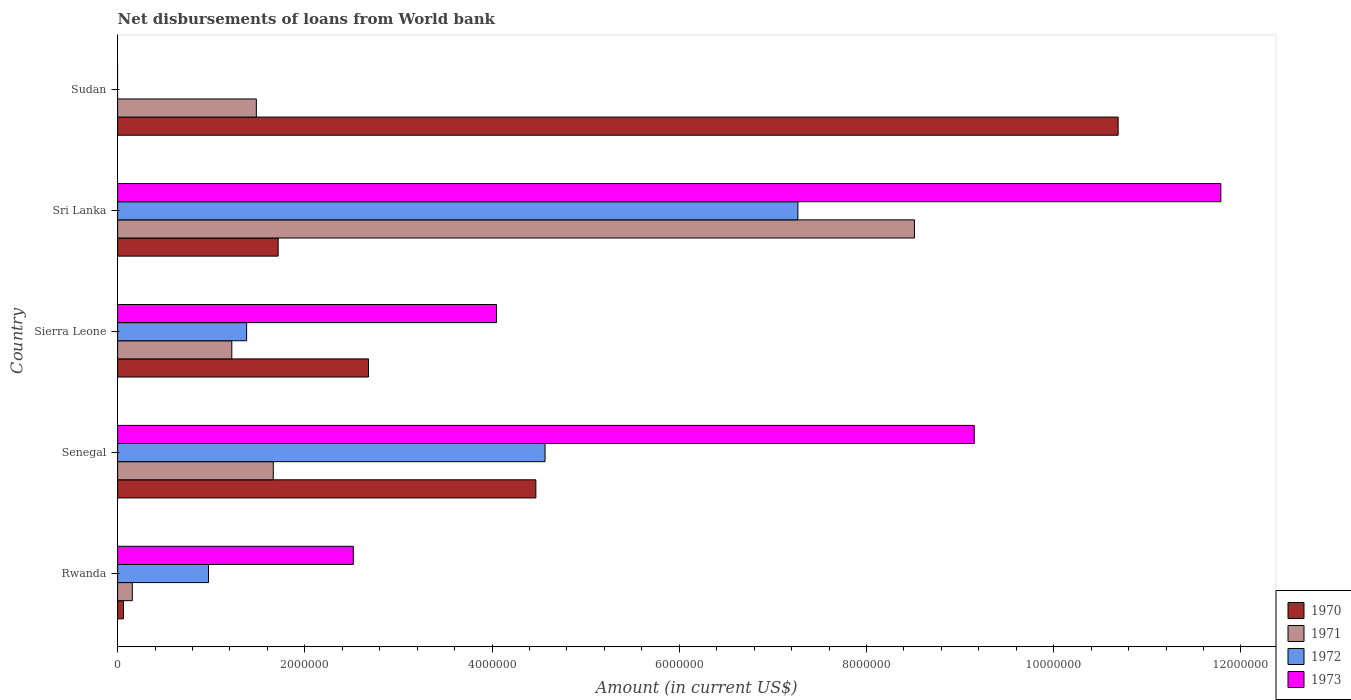How many different coloured bars are there?
Give a very brief answer. 4. How many groups of bars are there?
Your answer should be compact. 5. How many bars are there on the 5th tick from the top?
Ensure brevity in your answer.  4. What is the label of the 2nd group of bars from the top?
Ensure brevity in your answer.  Sri Lanka. What is the amount of loan disbursed from World Bank in 1972 in Sierra Leone?
Offer a very short reply. 1.38e+06. Across all countries, what is the maximum amount of loan disbursed from World Bank in 1971?
Your answer should be compact. 8.51e+06. Across all countries, what is the minimum amount of loan disbursed from World Bank in 1970?
Offer a very short reply. 6.30e+04. In which country was the amount of loan disbursed from World Bank in 1971 maximum?
Offer a very short reply. Sri Lanka. What is the total amount of loan disbursed from World Bank in 1970 in the graph?
Your answer should be very brief. 1.96e+07. What is the difference between the amount of loan disbursed from World Bank in 1971 in Senegal and that in Sri Lanka?
Your answer should be compact. -6.85e+06. What is the difference between the amount of loan disbursed from World Bank in 1971 in Sudan and the amount of loan disbursed from World Bank in 1973 in Rwanda?
Keep it short and to the point. -1.04e+06. What is the average amount of loan disbursed from World Bank in 1971 per country?
Provide a succinct answer. 2.61e+06. What is the difference between the amount of loan disbursed from World Bank in 1970 and amount of loan disbursed from World Bank in 1971 in Sudan?
Your answer should be compact. 9.21e+06. In how many countries, is the amount of loan disbursed from World Bank in 1971 greater than 8400000 US$?
Give a very brief answer. 1. What is the ratio of the amount of loan disbursed from World Bank in 1973 in Rwanda to that in Senegal?
Offer a very short reply. 0.28. Is the difference between the amount of loan disbursed from World Bank in 1970 in Senegal and Sri Lanka greater than the difference between the amount of loan disbursed from World Bank in 1971 in Senegal and Sri Lanka?
Give a very brief answer. Yes. What is the difference between the highest and the second highest amount of loan disbursed from World Bank in 1971?
Your response must be concise. 6.85e+06. What is the difference between the highest and the lowest amount of loan disbursed from World Bank in 1970?
Your answer should be very brief. 1.06e+07. Are all the bars in the graph horizontal?
Keep it short and to the point. Yes. What is the difference between two consecutive major ticks on the X-axis?
Provide a short and direct response. 2.00e+06. Where does the legend appear in the graph?
Your answer should be compact. Bottom right. How are the legend labels stacked?
Make the answer very short. Vertical. What is the title of the graph?
Your answer should be very brief. Net disbursements of loans from World bank. What is the label or title of the Y-axis?
Offer a very short reply. Country. What is the Amount (in current US$) of 1970 in Rwanda?
Keep it short and to the point. 6.30e+04. What is the Amount (in current US$) of 1971 in Rwanda?
Provide a short and direct response. 1.57e+05. What is the Amount (in current US$) of 1972 in Rwanda?
Give a very brief answer. 9.71e+05. What is the Amount (in current US$) in 1973 in Rwanda?
Ensure brevity in your answer.  2.52e+06. What is the Amount (in current US$) in 1970 in Senegal?
Ensure brevity in your answer.  4.47e+06. What is the Amount (in current US$) in 1971 in Senegal?
Make the answer very short. 1.66e+06. What is the Amount (in current US$) of 1972 in Senegal?
Make the answer very short. 4.57e+06. What is the Amount (in current US$) in 1973 in Senegal?
Offer a terse response. 9.15e+06. What is the Amount (in current US$) of 1970 in Sierra Leone?
Make the answer very short. 2.68e+06. What is the Amount (in current US$) of 1971 in Sierra Leone?
Your answer should be very brief. 1.22e+06. What is the Amount (in current US$) of 1972 in Sierra Leone?
Make the answer very short. 1.38e+06. What is the Amount (in current US$) in 1973 in Sierra Leone?
Provide a short and direct response. 4.05e+06. What is the Amount (in current US$) of 1970 in Sri Lanka?
Provide a short and direct response. 1.72e+06. What is the Amount (in current US$) of 1971 in Sri Lanka?
Offer a very short reply. 8.51e+06. What is the Amount (in current US$) of 1972 in Sri Lanka?
Make the answer very short. 7.27e+06. What is the Amount (in current US$) of 1973 in Sri Lanka?
Your answer should be very brief. 1.18e+07. What is the Amount (in current US$) in 1970 in Sudan?
Ensure brevity in your answer.  1.07e+07. What is the Amount (in current US$) in 1971 in Sudan?
Offer a very short reply. 1.48e+06. Across all countries, what is the maximum Amount (in current US$) of 1970?
Offer a very short reply. 1.07e+07. Across all countries, what is the maximum Amount (in current US$) of 1971?
Your answer should be compact. 8.51e+06. Across all countries, what is the maximum Amount (in current US$) of 1972?
Give a very brief answer. 7.27e+06. Across all countries, what is the maximum Amount (in current US$) of 1973?
Your answer should be compact. 1.18e+07. Across all countries, what is the minimum Amount (in current US$) of 1970?
Your answer should be compact. 6.30e+04. Across all countries, what is the minimum Amount (in current US$) of 1971?
Your answer should be compact. 1.57e+05. What is the total Amount (in current US$) in 1970 in the graph?
Your response must be concise. 1.96e+07. What is the total Amount (in current US$) in 1971 in the graph?
Give a very brief answer. 1.30e+07. What is the total Amount (in current US$) of 1972 in the graph?
Your answer should be very brief. 1.42e+07. What is the total Amount (in current US$) of 1973 in the graph?
Give a very brief answer. 2.75e+07. What is the difference between the Amount (in current US$) of 1970 in Rwanda and that in Senegal?
Your answer should be very brief. -4.40e+06. What is the difference between the Amount (in current US$) in 1971 in Rwanda and that in Senegal?
Give a very brief answer. -1.51e+06. What is the difference between the Amount (in current US$) of 1972 in Rwanda and that in Senegal?
Ensure brevity in your answer.  -3.60e+06. What is the difference between the Amount (in current US$) in 1973 in Rwanda and that in Senegal?
Ensure brevity in your answer.  -6.63e+06. What is the difference between the Amount (in current US$) of 1970 in Rwanda and that in Sierra Leone?
Provide a short and direct response. -2.62e+06. What is the difference between the Amount (in current US$) in 1971 in Rwanda and that in Sierra Leone?
Ensure brevity in your answer.  -1.06e+06. What is the difference between the Amount (in current US$) in 1972 in Rwanda and that in Sierra Leone?
Make the answer very short. -4.07e+05. What is the difference between the Amount (in current US$) of 1973 in Rwanda and that in Sierra Leone?
Your answer should be very brief. -1.53e+06. What is the difference between the Amount (in current US$) of 1970 in Rwanda and that in Sri Lanka?
Keep it short and to the point. -1.65e+06. What is the difference between the Amount (in current US$) of 1971 in Rwanda and that in Sri Lanka?
Ensure brevity in your answer.  -8.36e+06. What is the difference between the Amount (in current US$) in 1972 in Rwanda and that in Sri Lanka?
Keep it short and to the point. -6.30e+06. What is the difference between the Amount (in current US$) in 1973 in Rwanda and that in Sri Lanka?
Provide a succinct answer. -9.27e+06. What is the difference between the Amount (in current US$) of 1970 in Rwanda and that in Sudan?
Give a very brief answer. -1.06e+07. What is the difference between the Amount (in current US$) in 1971 in Rwanda and that in Sudan?
Offer a terse response. -1.32e+06. What is the difference between the Amount (in current US$) of 1970 in Senegal and that in Sierra Leone?
Your answer should be very brief. 1.79e+06. What is the difference between the Amount (in current US$) in 1971 in Senegal and that in Sierra Leone?
Your answer should be compact. 4.43e+05. What is the difference between the Amount (in current US$) of 1972 in Senegal and that in Sierra Leone?
Provide a succinct answer. 3.19e+06. What is the difference between the Amount (in current US$) of 1973 in Senegal and that in Sierra Leone?
Give a very brief answer. 5.10e+06. What is the difference between the Amount (in current US$) of 1970 in Senegal and that in Sri Lanka?
Your answer should be compact. 2.75e+06. What is the difference between the Amount (in current US$) of 1971 in Senegal and that in Sri Lanka?
Give a very brief answer. -6.85e+06. What is the difference between the Amount (in current US$) of 1972 in Senegal and that in Sri Lanka?
Make the answer very short. -2.70e+06. What is the difference between the Amount (in current US$) in 1973 in Senegal and that in Sri Lanka?
Offer a very short reply. -2.63e+06. What is the difference between the Amount (in current US$) of 1970 in Senegal and that in Sudan?
Your answer should be compact. -6.22e+06. What is the difference between the Amount (in current US$) in 1971 in Senegal and that in Sudan?
Your answer should be very brief. 1.81e+05. What is the difference between the Amount (in current US$) in 1970 in Sierra Leone and that in Sri Lanka?
Keep it short and to the point. 9.65e+05. What is the difference between the Amount (in current US$) of 1971 in Sierra Leone and that in Sri Lanka?
Your response must be concise. -7.29e+06. What is the difference between the Amount (in current US$) of 1972 in Sierra Leone and that in Sri Lanka?
Give a very brief answer. -5.89e+06. What is the difference between the Amount (in current US$) in 1973 in Sierra Leone and that in Sri Lanka?
Offer a terse response. -7.74e+06. What is the difference between the Amount (in current US$) of 1970 in Sierra Leone and that in Sudan?
Offer a terse response. -8.01e+06. What is the difference between the Amount (in current US$) in 1971 in Sierra Leone and that in Sudan?
Provide a succinct answer. -2.62e+05. What is the difference between the Amount (in current US$) in 1970 in Sri Lanka and that in Sudan?
Your answer should be very brief. -8.97e+06. What is the difference between the Amount (in current US$) of 1971 in Sri Lanka and that in Sudan?
Offer a terse response. 7.03e+06. What is the difference between the Amount (in current US$) in 1970 in Rwanda and the Amount (in current US$) in 1971 in Senegal?
Provide a succinct answer. -1.60e+06. What is the difference between the Amount (in current US$) of 1970 in Rwanda and the Amount (in current US$) of 1972 in Senegal?
Make the answer very short. -4.50e+06. What is the difference between the Amount (in current US$) in 1970 in Rwanda and the Amount (in current US$) in 1973 in Senegal?
Offer a terse response. -9.09e+06. What is the difference between the Amount (in current US$) in 1971 in Rwanda and the Amount (in current US$) in 1972 in Senegal?
Offer a terse response. -4.41e+06. What is the difference between the Amount (in current US$) in 1971 in Rwanda and the Amount (in current US$) in 1973 in Senegal?
Your response must be concise. -8.99e+06. What is the difference between the Amount (in current US$) in 1972 in Rwanda and the Amount (in current US$) in 1973 in Senegal?
Your answer should be compact. -8.18e+06. What is the difference between the Amount (in current US$) in 1970 in Rwanda and the Amount (in current US$) in 1971 in Sierra Leone?
Give a very brief answer. -1.16e+06. What is the difference between the Amount (in current US$) in 1970 in Rwanda and the Amount (in current US$) in 1972 in Sierra Leone?
Your answer should be compact. -1.32e+06. What is the difference between the Amount (in current US$) of 1970 in Rwanda and the Amount (in current US$) of 1973 in Sierra Leone?
Provide a short and direct response. -3.98e+06. What is the difference between the Amount (in current US$) of 1971 in Rwanda and the Amount (in current US$) of 1972 in Sierra Leone?
Offer a terse response. -1.22e+06. What is the difference between the Amount (in current US$) of 1971 in Rwanda and the Amount (in current US$) of 1973 in Sierra Leone?
Your response must be concise. -3.89e+06. What is the difference between the Amount (in current US$) of 1972 in Rwanda and the Amount (in current US$) of 1973 in Sierra Leone?
Your response must be concise. -3.08e+06. What is the difference between the Amount (in current US$) of 1970 in Rwanda and the Amount (in current US$) of 1971 in Sri Lanka?
Make the answer very short. -8.45e+06. What is the difference between the Amount (in current US$) of 1970 in Rwanda and the Amount (in current US$) of 1972 in Sri Lanka?
Your response must be concise. -7.20e+06. What is the difference between the Amount (in current US$) of 1970 in Rwanda and the Amount (in current US$) of 1973 in Sri Lanka?
Your response must be concise. -1.17e+07. What is the difference between the Amount (in current US$) in 1971 in Rwanda and the Amount (in current US$) in 1972 in Sri Lanka?
Your answer should be compact. -7.11e+06. What is the difference between the Amount (in current US$) in 1971 in Rwanda and the Amount (in current US$) in 1973 in Sri Lanka?
Your response must be concise. -1.16e+07. What is the difference between the Amount (in current US$) in 1972 in Rwanda and the Amount (in current US$) in 1973 in Sri Lanka?
Offer a very short reply. -1.08e+07. What is the difference between the Amount (in current US$) of 1970 in Rwanda and the Amount (in current US$) of 1971 in Sudan?
Your answer should be compact. -1.42e+06. What is the difference between the Amount (in current US$) in 1970 in Senegal and the Amount (in current US$) in 1971 in Sierra Leone?
Provide a succinct answer. 3.25e+06. What is the difference between the Amount (in current US$) in 1970 in Senegal and the Amount (in current US$) in 1972 in Sierra Leone?
Offer a very short reply. 3.09e+06. What is the difference between the Amount (in current US$) of 1971 in Senegal and the Amount (in current US$) of 1972 in Sierra Leone?
Offer a terse response. 2.85e+05. What is the difference between the Amount (in current US$) in 1971 in Senegal and the Amount (in current US$) in 1973 in Sierra Leone?
Give a very brief answer. -2.38e+06. What is the difference between the Amount (in current US$) of 1972 in Senegal and the Amount (in current US$) of 1973 in Sierra Leone?
Offer a terse response. 5.18e+05. What is the difference between the Amount (in current US$) of 1970 in Senegal and the Amount (in current US$) of 1971 in Sri Lanka?
Offer a terse response. -4.04e+06. What is the difference between the Amount (in current US$) of 1970 in Senegal and the Amount (in current US$) of 1972 in Sri Lanka?
Offer a terse response. -2.80e+06. What is the difference between the Amount (in current US$) in 1970 in Senegal and the Amount (in current US$) in 1973 in Sri Lanka?
Your answer should be very brief. -7.32e+06. What is the difference between the Amount (in current US$) in 1971 in Senegal and the Amount (in current US$) in 1972 in Sri Lanka?
Ensure brevity in your answer.  -5.60e+06. What is the difference between the Amount (in current US$) in 1971 in Senegal and the Amount (in current US$) in 1973 in Sri Lanka?
Your answer should be very brief. -1.01e+07. What is the difference between the Amount (in current US$) in 1972 in Senegal and the Amount (in current US$) in 1973 in Sri Lanka?
Make the answer very short. -7.22e+06. What is the difference between the Amount (in current US$) of 1970 in Senegal and the Amount (in current US$) of 1971 in Sudan?
Your answer should be compact. 2.99e+06. What is the difference between the Amount (in current US$) in 1970 in Sierra Leone and the Amount (in current US$) in 1971 in Sri Lanka?
Your answer should be very brief. -5.83e+06. What is the difference between the Amount (in current US$) of 1970 in Sierra Leone and the Amount (in current US$) of 1972 in Sri Lanka?
Offer a terse response. -4.59e+06. What is the difference between the Amount (in current US$) in 1970 in Sierra Leone and the Amount (in current US$) in 1973 in Sri Lanka?
Keep it short and to the point. -9.10e+06. What is the difference between the Amount (in current US$) of 1971 in Sierra Leone and the Amount (in current US$) of 1972 in Sri Lanka?
Make the answer very short. -6.05e+06. What is the difference between the Amount (in current US$) in 1971 in Sierra Leone and the Amount (in current US$) in 1973 in Sri Lanka?
Your response must be concise. -1.06e+07. What is the difference between the Amount (in current US$) in 1972 in Sierra Leone and the Amount (in current US$) in 1973 in Sri Lanka?
Your answer should be very brief. -1.04e+07. What is the difference between the Amount (in current US$) of 1970 in Sierra Leone and the Amount (in current US$) of 1971 in Sudan?
Offer a very short reply. 1.20e+06. What is the difference between the Amount (in current US$) in 1970 in Sri Lanka and the Amount (in current US$) in 1971 in Sudan?
Ensure brevity in your answer.  2.33e+05. What is the average Amount (in current US$) in 1970 per country?
Give a very brief answer. 3.92e+06. What is the average Amount (in current US$) in 1971 per country?
Provide a succinct answer. 2.61e+06. What is the average Amount (in current US$) of 1972 per country?
Offer a very short reply. 2.84e+06. What is the average Amount (in current US$) of 1973 per country?
Your answer should be compact. 5.50e+06. What is the difference between the Amount (in current US$) in 1970 and Amount (in current US$) in 1971 in Rwanda?
Provide a short and direct response. -9.40e+04. What is the difference between the Amount (in current US$) of 1970 and Amount (in current US$) of 1972 in Rwanda?
Provide a short and direct response. -9.08e+05. What is the difference between the Amount (in current US$) of 1970 and Amount (in current US$) of 1973 in Rwanda?
Your answer should be very brief. -2.46e+06. What is the difference between the Amount (in current US$) of 1971 and Amount (in current US$) of 1972 in Rwanda?
Make the answer very short. -8.14e+05. What is the difference between the Amount (in current US$) in 1971 and Amount (in current US$) in 1973 in Rwanda?
Your answer should be very brief. -2.36e+06. What is the difference between the Amount (in current US$) of 1972 and Amount (in current US$) of 1973 in Rwanda?
Offer a terse response. -1.55e+06. What is the difference between the Amount (in current US$) of 1970 and Amount (in current US$) of 1971 in Senegal?
Your response must be concise. 2.80e+06. What is the difference between the Amount (in current US$) in 1970 and Amount (in current US$) in 1972 in Senegal?
Your answer should be very brief. -9.80e+04. What is the difference between the Amount (in current US$) in 1970 and Amount (in current US$) in 1973 in Senegal?
Your answer should be compact. -4.68e+06. What is the difference between the Amount (in current US$) in 1971 and Amount (in current US$) in 1972 in Senegal?
Keep it short and to the point. -2.90e+06. What is the difference between the Amount (in current US$) of 1971 and Amount (in current US$) of 1973 in Senegal?
Offer a terse response. -7.49e+06. What is the difference between the Amount (in current US$) of 1972 and Amount (in current US$) of 1973 in Senegal?
Your response must be concise. -4.58e+06. What is the difference between the Amount (in current US$) of 1970 and Amount (in current US$) of 1971 in Sierra Leone?
Give a very brief answer. 1.46e+06. What is the difference between the Amount (in current US$) in 1970 and Amount (in current US$) in 1972 in Sierra Leone?
Keep it short and to the point. 1.30e+06. What is the difference between the Amount (in current US$) of 1970 and Amount (in current US$) of 1973 in Sierra Leone?
Make the answer very short. -1.37e+06. What is the difference between the Amount (in current US$) in 1971 and Amount (in current US$) in 1972 in Sierra Leone?
Make the answer very short. -1.58e+05. What is the difference between the Amount (in current US$) in 1971 and Amount (in current US$) in 1973 in Sierra Leone?
Give a very brief answer. -2.83e+06. What is the difference between the Amount (in current US$) in 1972 and Amount (in current US$) in 1973 in Sierra Leone?
Provide a succinct answer. -2.67e+06. What is the difference between the Amount (in current US$) of 1970 and Amount (in current US$) of 1971 in Sri Lanka?
Offer a terse response. -6.80e+06. What is the difference between the Amount (in current US$) of 1970 and Amount (in current US$) of 1972 in Sri Lanka?
Provide a short and direct response. -5.55e+06. What is the difference between the Amount (in current US$) of 1970 and Amount (in current US$) of 1973 in Sri Lanka?
Your answer should be very brief. -1.01e+07. What is the difference between the Amount (in current US$) in 1971 and Amount (in current US$) in 1972 in Sri Lanka?
Ensure brevity in your answer.  1.24e+06. What is the difference between the Amount (in current US$) in 1971 and Amount (in current US$) in 1973 in Sri Lanka?
Keep it short and to the point. -3.27e+06. What is the difference between the Amount (in current US$) of 1972 and Amount (in current US$) of 1973 in Sri Lanka?
Make the answer very short. -4.52e+06. What is the difference between the Amount (in current US$) in 1970 and Amount (in current US$) in 1971 in Sudan?
Give a very brief answer. 9.21e+06. What is the ratio of the Amount (in current US$) in 1970 in Rwanda to that in Senegal?
Give a very brief answer. 0.01. What is the ratio of the Amount (in current US$) in 1971 in Rwanda to that in Senegal?
Keep it short and to the point. 0.09. What is the ratio of the Amount (in current US$) of 1972 in Rwanda to that in Senegal?
Provide a succinct answer. 0.21. What is the ratio of the Amount (in current US$) in 1973 in Rwanda to that in Senegal?
Your answer should be very brief. 0.28. What is the ratio of the Amount (in current US$) of 1970 in Rwanda to that in Sierra Leone?
Make the answer very short. 0.02. What is the ratio of the Amount (in current US$) of 1971 in Rwanda to that in Sierra Leone?
Your answer should be compact. 0.13. What is the ratio of the Amount (in current US$) of 1972 in Rwanda to that in Sierra Leone?
Offer a very short reply. 0.7. What is the ratio of the Amount (in current US$) of 1973 in Rwanda to that in Sierra Leone?
Provide a short and direct response. 0.62. What is the ratio of the Amount (in current US$) of 1970 in Rwanda to that in Sri Lanka?
Offer a very short reply. 0.04. What is the ratio of the Amount (in current US$) of 1971 in Rwanda to that in Sri Lanka?
Your answer should be very brief. 0.02. What is the ratio of the Amount (in current US$) of 1972 in Rwanda to that in Sri Lanka?
Offer a terse response. 0.13. What is the ratio of the Amount (in current US$) in 1973 in Rwanda to that in Sri Lanka?
Give a very brief answer. 0.21. What is the ratio of the Amount (in current US$) of 1970 in Rwanda to that in Sudan?
Provide a succinct answer. 0.01. What is the ratio of the Amount (in current US$) of 1971 in Rwanda to that in Sudan?
Your answer should be compact. 0.11. What is the ratio of the Amount (in current US$) in 1970 in Senegal to that in Sierra Leone?
Ensure brevity in your answer.  1.67. What is the ratio of the Amount (in current US$) of 1971 in Senegal to that in Sierra Leone?
Give a very brief answer. 1.36. What is the ratio of the Amount (in current US$) of 1972 in Senegal to that in Sierra Leone?
Your answer should be compact. 3.31. What is the ratio of the Amount (in current US$) in 1973 in Senegal to that in Sierra Leone?
Provide a short and direct response. 2.26. What is the ratio of the Amount (in current US$) in 1970 in Senegal to that in Sri Lanka?
Keep it short and to the point. 2.61. What is the ratio of the Amount (in current US$) of 1971 in Senegal to that in Sri Lanka?
Offer a very short reply. 0.2. What is the ratio of the Amount (in current US$) in 1972 in Senegal to that in Sri Lanka?
Your answer should be very brief. 0.63. What is the ratio of the Amount (in current US$) in 1973 in Senegal to that in Sri Lanka?
Ensure brevity in your answer.  0.78. What is the ratio of the Amount (in current US$) of 1970 in Senegal to that in Sudan?
Offer a terse response. 0.42. What is the ratio of the Amount (in current US$) of 1971 in Senegal to that in Sudan?
Offer a terse response. 1.12. What is the ratio of the Amount (in current US$) in 1970 in Sierra Leone to that in Sri Lanka?
Give a very brief answer. 1.56. What is the ratio of the Amount (in current US$) of 1971 in Sierra Leone to that in Sri Lanka?
Keep it short and to the point. 0.14. What is the ratio of the Amount (in current US$) in 1972 in Sierra Leone to that in Sri Lanka?
Provide a succinct answer. 0.19. What is the ratio of the Amount (in current US$) in 1973 in Sierra Leone to that in Sri Lanka?
Offer a terse response. 0.34. What is the ratio of the Amount (in current US$) of 1970 in Sierra Leone to that in Sudan?
Provide a succinct answer. 0.25. What is the ratio of the Amount (in current US$) of 1971 in Sierra Leone to that in Sudan?
Ensure brevity in your answer.  0.82. What is the ratio of the Amount (in current US$) in 1970 in Sri Lanka to that in Sudan?
Your response must be concise. 0.16. What is the ratio of the Amount (in current US$) of 1971 in Sri Lanka to that in Sudan?
Your answer should be compact. 5.74. What is the difference between the highest and the second highest Amount (in current US$) in 1970?
Keep it short and to the point. 6.22e+06. What is the difference between the highest and the second highest Amount (in current US$) in 1971?
Your answer should be compact. 6.85e+06. What is the difference between the highest and the second highest Amount (in current US$) in 1972?
Keep it short and to the point. 2.70e+06. What is the difference between the highest and the second highest Amount (in current US$) of 1973?
Your answer should be compact. 2.63e+06. What is the difference between the highest and the lowest Amount (in current US$) of 1970?
Offer a terse response. 1.06e+07. What is the difference between the highest and the lowest Amount (in current US$) of 1971?
Provide a succinct answer. 8.36e+06. What is the difference between the highest and the lowest Amount (in current US$) in 1972?
Offer a very short reply. 7.27e+06. What is the difference between the highest and the lowest Amount (in current US$) in 1973?
Offer a terse response. 1.18e+07. 